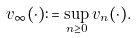<formula> <loc_0><loc_0><loc_500><loc_500>v _ { \infty } ( \cdot ) \colon = \sup _ { n \geq 0 } v _ { n } ( \cdot ) .</formula> 